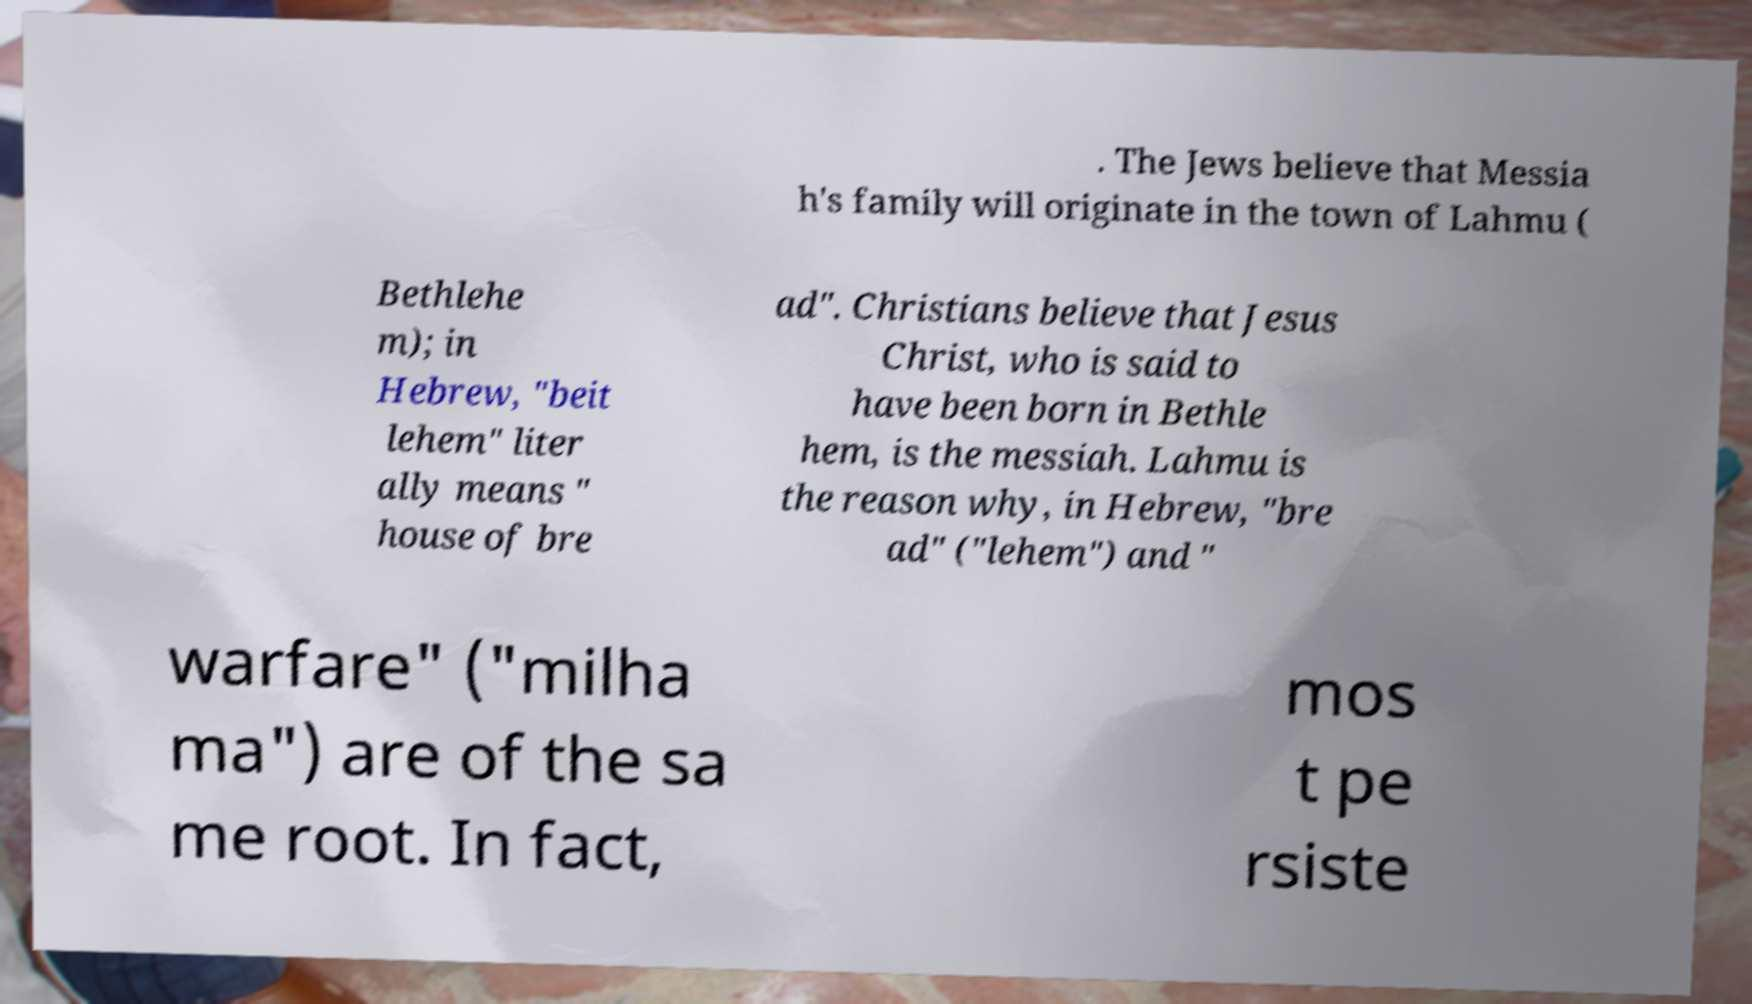There's text embedded in this image that I need extracted. Can you transcribe it verbatim? . The Jews believe that Messia h's family will originate in the town of Lahmu ( Bethlehe m); in Hebrew, "beit lehem" liter ally means " house of bre ad". Christians believe that Jesus Christ, who is said to have been born in Bethle hem, is the messiah. Lahmu is the reason why, in Hebrew, "bre ad" ("lehem") and " warfare" ("milha ma") are of the sa me root. In fact, mos t pe rsiste 